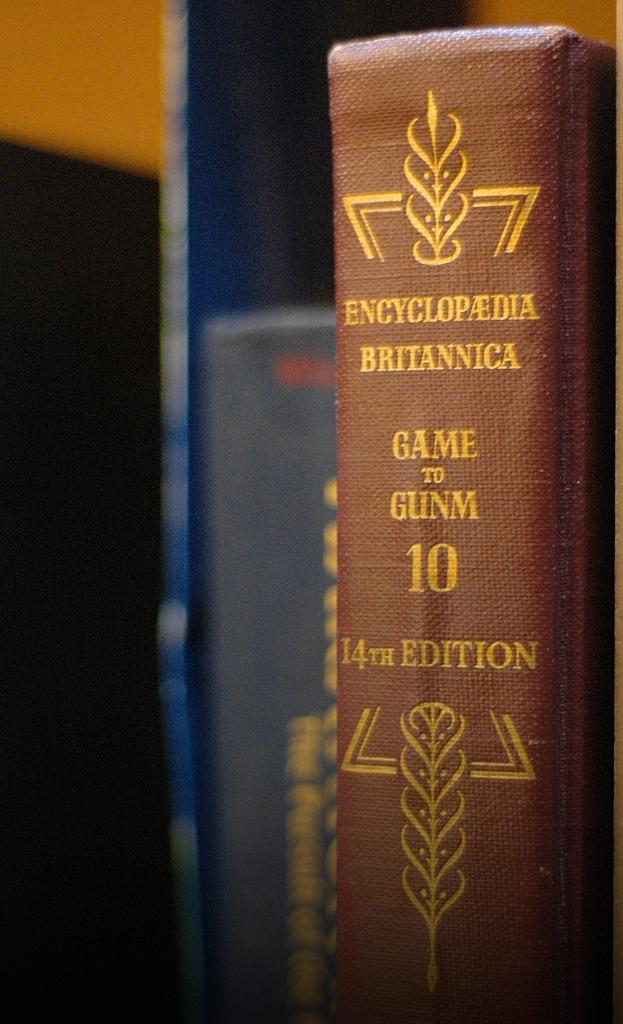<image>
Present a compact description of the photo's key features. Book number 10 in the 14th edition of the Encyclopedia Britannica sits next to another book. 